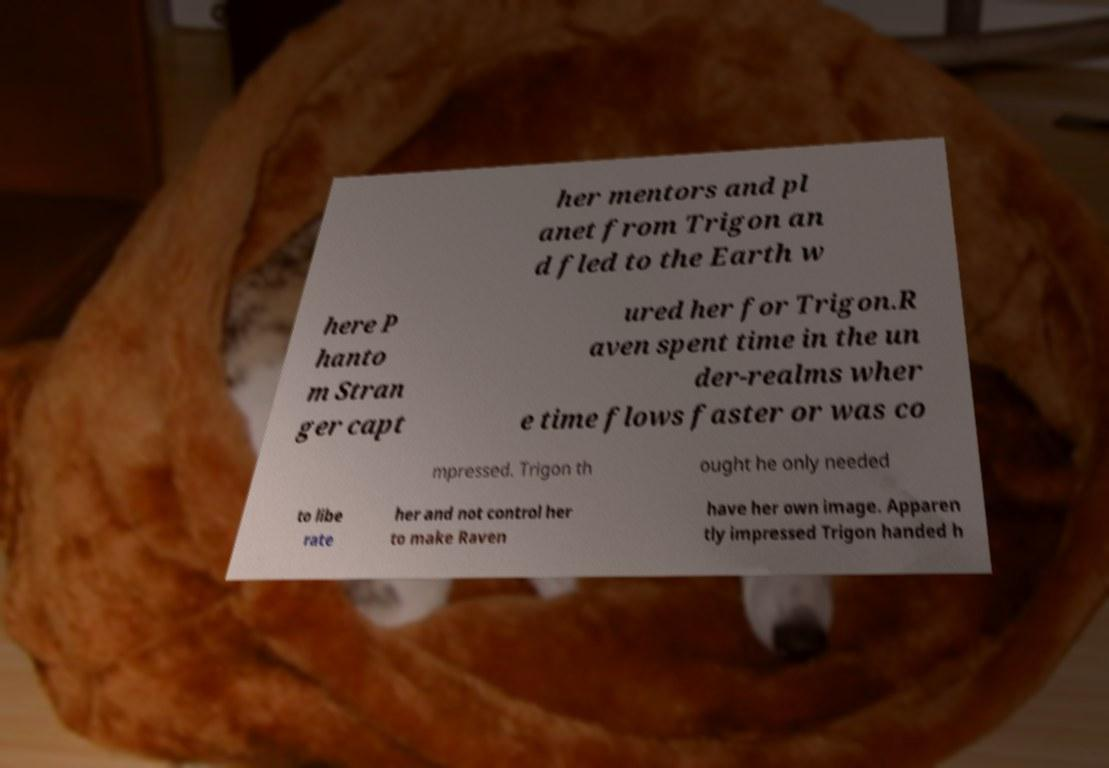Can you read and provide the text displayed in the image?This photo seems to have some interesting text. Can you extract and type it out for me? her mentors and pl anet from Trigon an d fled to the Earth w here P hanto m Stran ger capt ured her for Trigon.R aven spent time in the un der-realms wher e time flows faster or was co mpressed. Trigon th ought he only needed to libe rate her and not control her to make Raven have her own image. Apparen tly impressed Trigon handed h 